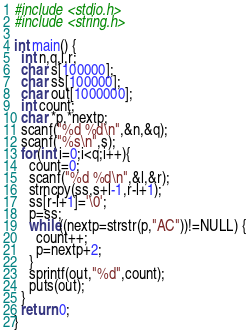<code> <loc_0><loc_0><loc_500><loc_500><_C_>#include <stdio.h>
#include <string.h>

int main() {
  int n,q,l,r;
  char s[100000];
  char ss[100000];
  char out[1000000];
  int count;
  char *p,*nextp;
  scanf("%d %d\n",&n,&q);
  scanf("%s\n",s);
  for(int i=0;i<q;i++){
    count=0;
    scanf("%d %d\n",&l,&r);
    strncpy(ss,s+l-1,r-l+1);
    ss[r-l+1]='\0';
    p=ss;
    while((nextp=strstr(p,"AC"))!=NULL) {
      count++;
      p=nextp+2;
    }
    sprintf(out,"%d",count);
    puts(out);
  }
  return 0;
}</code> 